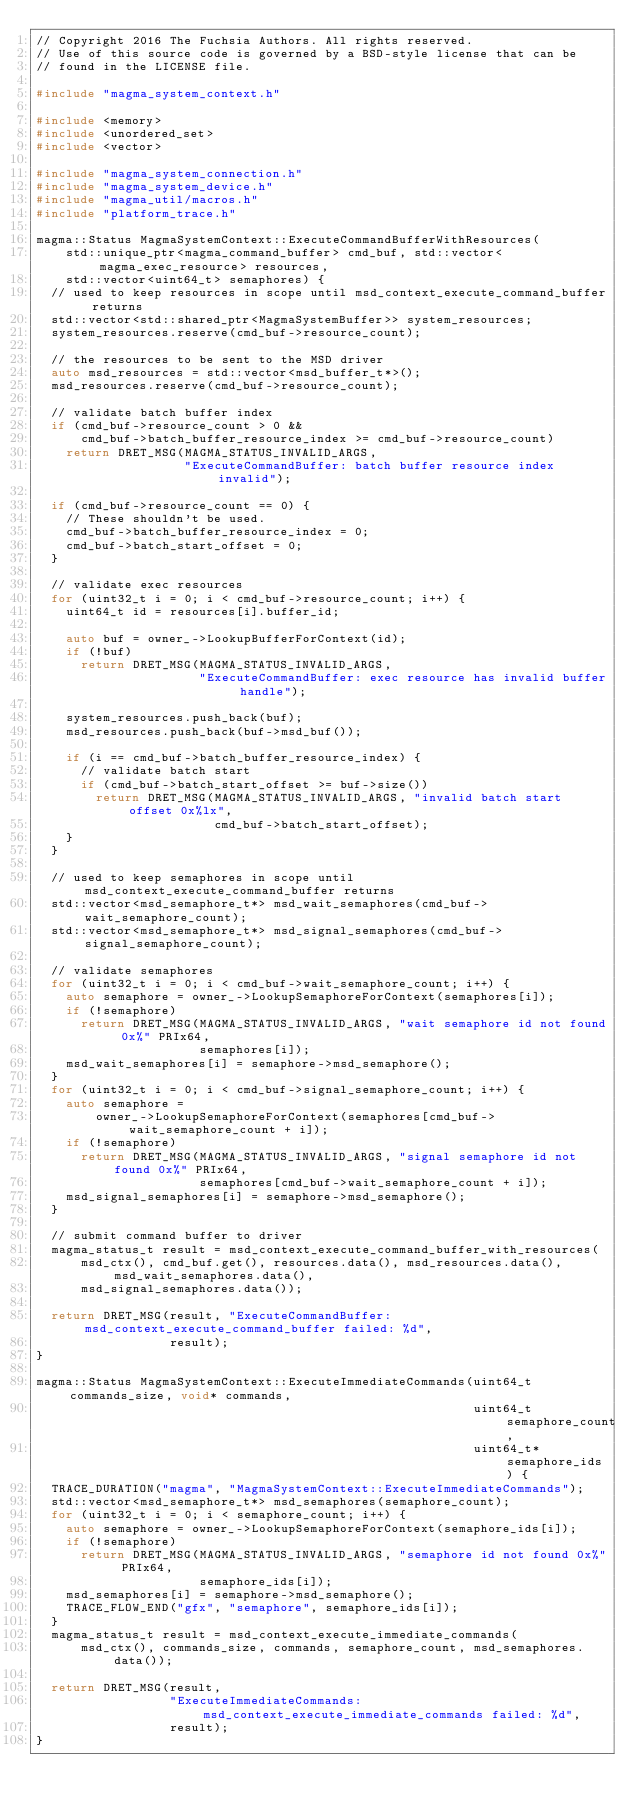Convert code to text. <code><loc_0><loc_0><loc_500><loc_500><_C++_>// Copyright 2016 The Fuchsia Authors. All rights reserved.
// Use of this source code is governed by a BSD-style license that can be
// found in the LICENSE file.

#include "magma_system_context.h"

#include <memory>
#include <unordered_set>
#include <vector>

#include "magma_system_connection.h"
#include "magma_system_device.h"
#include "magma_util/macros.h"
#include "platform_trace.h"

magma::Status MagmaSystemContext::ExecuteCommandBufferWithResources(
    std::unique_ptr<magma_command_buffer> cmd_buf, std::vector<magma_exec_resource> resources,
    std::vector<uint64_t> semaphores) {
  // used to keep resources in scope until msd_context_execute_command_buffer returns
  std::vector<std::shared_ptr<MagmaSystemBuffer>> system_resources;
  system_resources.reserve(cmd_buf->resource_count);

  // the resources to be sent to the MSD driver
  auto msd_resources = std::vector<msd_buffer_t*>();
  msd_resources.reserve(cmd_buf->resource_count);

  // validate batch buffer index
  if (cmd_buf->resource_count > 0 &&
      cmd_buf->batch_buffer_resource_index >= cmd_buf->resource_count)
    return DRET_MSG(MAGMA_STATUS_INVALID_ARGS,
                    "ExecuteCommandBuffer: batch buffer resource index invalid");

  if (cmd_buf->resource_count == 0) {
    // These shouldn't be used.
    cmd_buf->batch_buffer_resource_index = 0;
    cmd_buf->batch_start_offset = 0;
  }

  // validate exec resources
  for (uint32_t i = 0; i < cmd_buf->resource_count; i++) {
    uint64_t id = resources[i].buffer_id;

    auto buf = owner_->LookupBufferForContext(id);
    if (!buf)
      return DRET_MSG(MAGMA_STATUS_INVALID_ARGS,
                      "ExecuteCommandBuffer: exec resource has invalid buffer handle");

    system_resources.push_back(buf);
    msd_resources.push_back(buf->msd_buf());

    if (i == cmd_buf->batch_buffer_resource_index) {
      // validate batch start
      if (cmd_buf->batch_start_offset >= buf->size())
        return DRET_MSG(MAGMA_STATUS_INVALID_ARGS, "invalid batch start offset 0x%lx",
                        cmd_buf->batch_start_offset);
    }
  }

  // used to keep semaphores in scope until msd_context_execute_command_buffer returns
  std::vector<msd_semaphore_t*> msd_wait_semaphores(cmd_buf->wait_semaphore_count);
  std::vector<msd_semaphore_t*> msd_signal_semaphores(cmd_buf->signal_semaphore_count);

  // validate semaphores
  for (uint32_t i = 0; i < cmd_buf->wait_semaphore_count; i++) {
    auto semaphore = owner_->LookupSemaphoreForContext(semaphores[i]);
    if (!semaphore)
      return DRET_MSG(MAGMA_STATUS_INVALID_ARGS, "wait semaphore id not found 0x%" PRIx64,
                      semaphores[i]);
    msd_wait_semaphores[i] = semaphore->msd_semaphore();
  }
  for (uint32_t i = 0; i < cmd_buf->signal_semaphore_count; i++) {
    auto semaphore =
        owner_->LookupSemaphoreForContext(semaphores[cmd_buf->wait_semaphore_count + i]);
    if (!semaphore)
      return DRET_MSG(MAGMA_STATUS_INVALID_ARGS, "signal semaphore id not found 0x%" PRIx64,
                      semaphores[cmd_buf->wait_semaphore_count + i]);
    msd_signal_semaphores[i] = semaphore->msd_semaphore();
  }

  // submit command buffer to driver
  magma_status_t result = msd_context_execute_command_buffer_with_resources(
      msd_ctx(), cmd_buf.get(), resources.data(), msd_resources.data(), msd_wait_semaphores.data(),
      msd_signal_semaphores.data());

  return DRET_MSG(result, "ExecuteCommandBuffer: msd_context_execute_command_buffer failed: %d",
                  result);
}

magma::Status MagmaSystemContext::ExecuteImmediateCommands(uint64_t commands_size, void* commands,
                                                           uint64_t semaphore_count,
                                                           uint64_t* semaphore_ids) {
  TRACE_DURATION("magma", "MagmaSystemContext::ExecuteImmediateCommands");
  std::vector<msd_semaphore_t*> msd_semaphores(semaphore_count);
  for (uint32_t i = 0; i < semaphore_count; i++) {
    auto semaphore = owner_->LookupSemaphoreForContext(semaphore_ids[i]);
    if (!semaphore)
      return DRET_MSG(MAGMA_STATUS_INVALID_ARGS, "semaphore id not found 0x%" PRIx64,
                      semaphore_ids[i]);
    msd_semaphores[i] = semaphore->msd_semaphore();
    TRACE_FLOW_END("gfx", "semaphore", semaphore_ids[i]);
  }
  magma_status_t result = msd_context_execute_immediate_commands(
      msd_ctx(), commands_size, commands, semaphore_count, msd_semaphores.data());

  return DRET_MSG(result,
                  "ExecuteImmediateCommands: msd_context_execute_immediate_commands failed: %d",
                  result);
}
</code> 